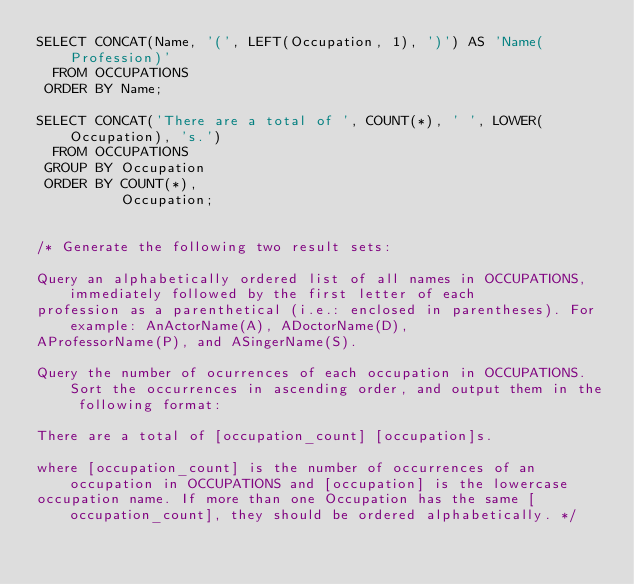Convert code to text. <code><loc_0><loc_0><loc_500><loc_500><_SQL_>SELECT CONCAT(Name, '(', LEFT(Occupation, 1), ')') AS 'Name(Profession)'
  FROM OCCUPATIONS
 ORDER BY Name;

SELECT CONCAT('There are a total of ', COUNT(*), ' ', LOWER(Occupation), 's.')
  FROM OCCUPATIONS
 GROUP BY Occupation
 ORDER BY COUNT(*),
          Occupation;


/* Generate the following two result sets:

Query an alphabetically ordered list of all names in OCCUPATIONS, immediately followed by the first letter of each 
profession as a parenthetical (i.e.: enclosed in parentheses). For example: AnActorName(A), ADoctorName(D), 
AProfessorName(P), and ASingerName(S).

Query the number of ocurrences of each occupation in OCCUPATIONS. Sort the occurrences in ascending order, and output them in the following format:

There are a total of [occupation_count] [occupation]s.

where [occupation_count] is the number of occurrences of an occupation in OCCUPATIONS and [occupation] is the lowercase 
occupation name. If more than one Occupation has the same [occupation_count], they should be ordered alphabetically. */</code> 